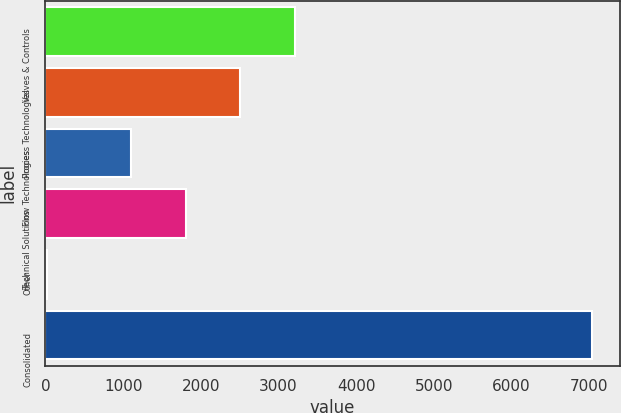Convert chart. <chart><loc_0><loc_0><loc_500><loc_500><bar_chart><fcel>Valves & Controls<fcel>Process Technologies<fcel>Flow Technologies<fcel>Technical Solutions<fcel>Other<fcel>Consolidated<nl><fcel>3211.19<fcel>2509.66<fcel>1106.6<fcel>1808.13<fcel>23.7<fcel>7039<nl></chart> 